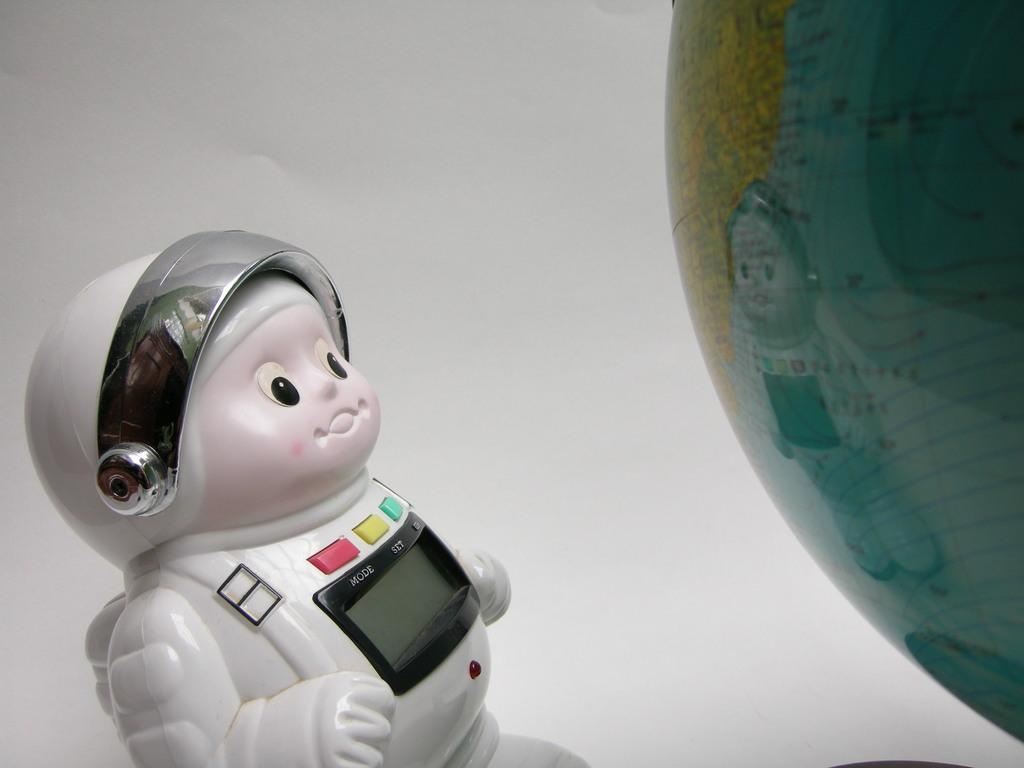What type of toy can be seen in the bottom right of the image? There is an astronaut toy in the bottom right of the image. What object in the image might display information or visuals? There is a screen in the image. What type of interactive elements are present in the image? There are buttons in the image. What type of spherical object is in the image? There is a globe ball in the image. What color is the wall visible in the image? There is a white color wall in the image. How many balls are being observed by the astronaut toy in the image? There are no balls being observed by the astronaut toy in the image. What type of base is supporting the screen in the image? There is no base supporting the screen in the image; it is not mentioned in the provided facts. 